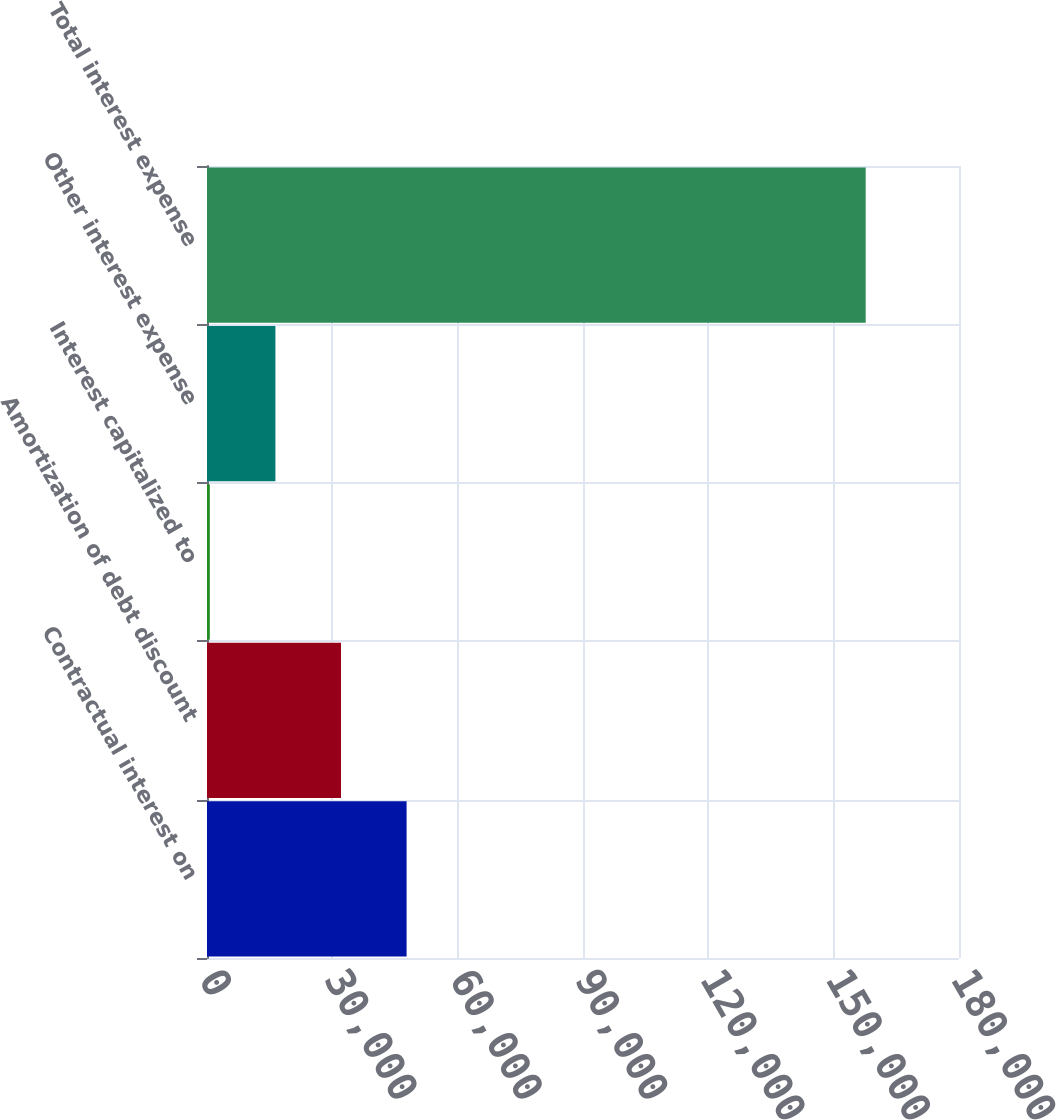Convert chart. <chart><loc_0><loc_0><loc_500><loc_500><bar_chart><fcel>Contractual interest on<fcel>Amortization of debt discount<fcel>Interest capitalized to<fcel>Other interest expense<fcel>Total interest expense<nl><fcel>47773.3<fcel>32074.2<fcel>676<fcel>16375.1<fcel>157667<nl></chart> 